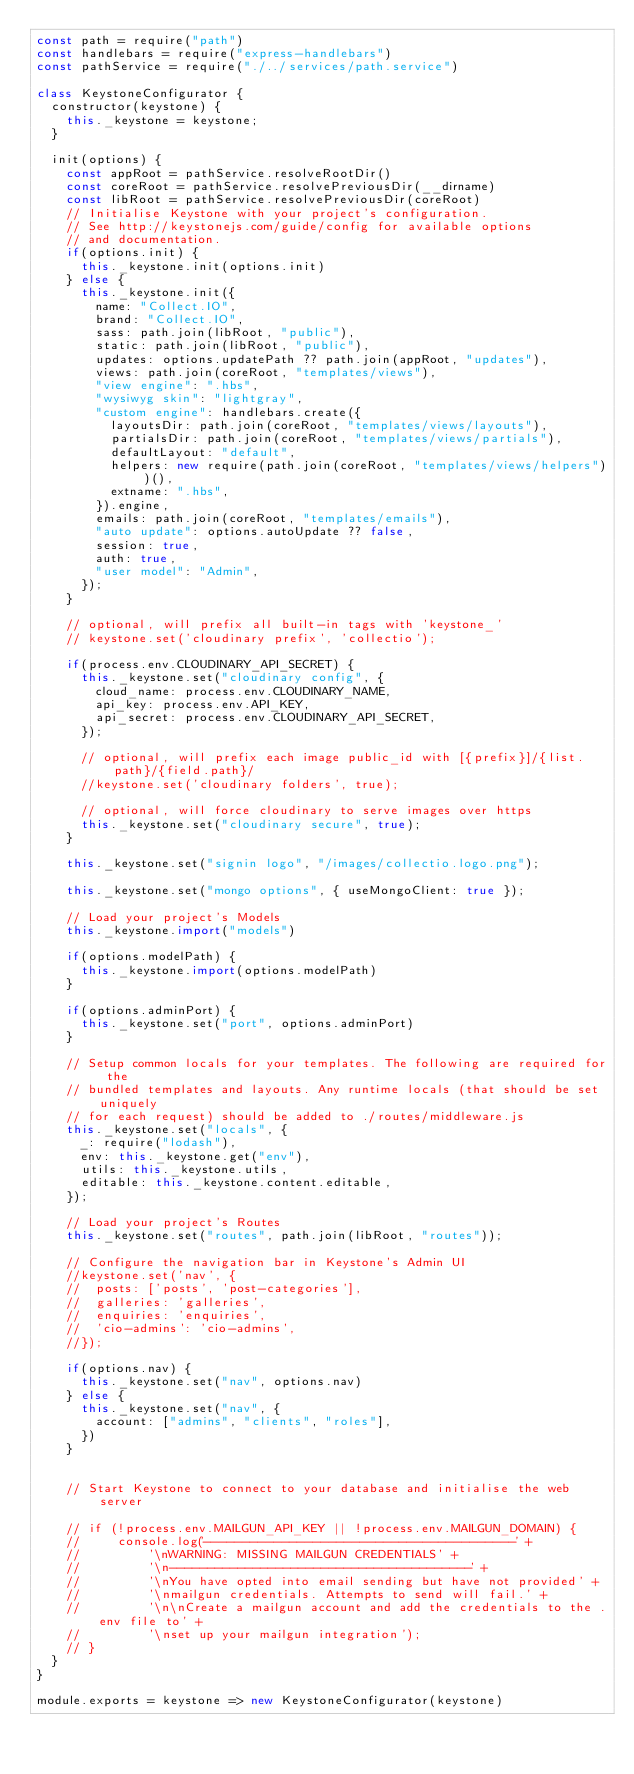Convert code to text. <code><loc_0><loc_0><loc_500><loc_500><_JavaScript_>const path = require("path")
const handlebars = require("express-handlebars")
const pathService = require("./../services/path.service")

class KeystoneConfigurator {
	constructor(keystone) {
		this._keystone = keystone;
	}

	init(options) {
		const appRoot = pathService.resolveRootDir()
		const coreRoot = pathService.resolvePreviousDir(__dirname)
		const libRoot = pathService.resolvePreviousDir(coreRoot)
		// Initialise Keystone with your project's configuration.
		// See http://keystonejs.com/guide/config for available options
		// and documentation.
		if(options.init) {
			this._keystone.init(options.init)
		} else {
			this._keystone.init({
				name: "Collect.IO",
				brand: "Collect.IO",
				sass: path.join(libRoot, "public"),
				static: path.join(libRoot, "public"),
				updates: options.updatePath ?? path.join(appRoot, "updates"),
				views: path.join(coreRoot, "templates/views"),
				"view engine": ".hbs",
				"wysiwyg skin": "lightgray",
				"custom engine": handlebars.create({
					layoutsDir: path.join(coreRoot, "templates/views/layouts"),
					partialsDir: path.join(coreRoot, "templates/views/partials"),
					defaultLayout: "default",
					helpers: new require(path.join(coreRoot, "templates/views/helpers"))(),
					extname: ".hbs",
				}).engine,
				emails: path.join(coreRoot, "templates/emails"),
				"auto update": options.autoUpdate ?? false,
				session: true,
				auth: true,
				"user model": "Admin",
			});
		}

		// optional, will prefix all built-in tags with 'keystone_'
		// keystone.set('cloudinary prefix', 'collectio');

		if(process.env.CLOUDINARY_API_SECRET) {
			this._keystone.set("cloudinary config", {
				cloud_name: process.env.CLOUDINARY_NAME,
				api_key: process.env.API_KEY,
				api_secret: process.env.CLOUDINARY_API_SECRET,
			});

			// optional, will prefix each image public_id with [{prefix}]/{list.path}/{field.path}/
			//keystone.set('cloudinary folders', true);

			// optional, will force cloudinary to serve images over https
			this._keystone.set("cloudinary secure", true);
		}

		this._keystone.set("signin logo", "/images/collectio.logo.png");

		this._keystone.set("mongo options", { useMongoClient: true });

		// Load your project's Models
		this._keystone.import("models")

		if(options.modelPath) {
			this._keystone.import(options.modelPath)
		}

		if(options.adminPort) {
			this._keystone.set("port", options.adminPort)
		}

		// Setup common locals for your templates. The following are required for the
		// bundled templates and layouts. Any runtime locals (that should be set uniquely
		// for each request) should be added to ./routes/middleware.js
		this._keystone.set("locals", {
			_: require("lodash"),
			env: this._keystone.get("env"),
			utils: this._keystone.utils,
			editable: this._keystone.content.editable,
		});

		// Load your project's Routes
		this._keystone.set("routes", path.join(libRoot, "routes"));

		// Configure the navigation bar in Keystone's Admin UI
		//keystone.set('nav', {
		//	posts: ['posts', 'post-categories'],
		//	galleries: 'galleries',
		//	enquiries: 'enquiries',
		//	'cio-admins': 'cio-admins',
		//});

		if(options.nav) {
			this._keystone.set("nav", options.nav)
		} else {
			this._keystone.set("nav", {
				account: ["admins", "clients", "roles"],
			})
		}


		// Start Keystone to connect to your database and initialise the web server

		// if (!process.env.MAILGUN_API_KEY || !process.env.MAILGUN_DOMAIN) {
		//     console.log('----------------------------------------' +
		//         '\nWARNING: MISSING MAILGUN CREDENTIALS' +
		//         '\n----------------------------------------' +
		//         '\nYou have opted into email sending but have not provided' +
		//         '\nmailgun credentials. Attempts to send will fail.' +
		//         '\n\nCreate a mailgun account and add the credentials to the .env file to' +
		//         '\nset up your mailgun integration');
		// }
	}
}

module.exports = keystone => new KeystoneConfigurator(keystone) 
</code> 